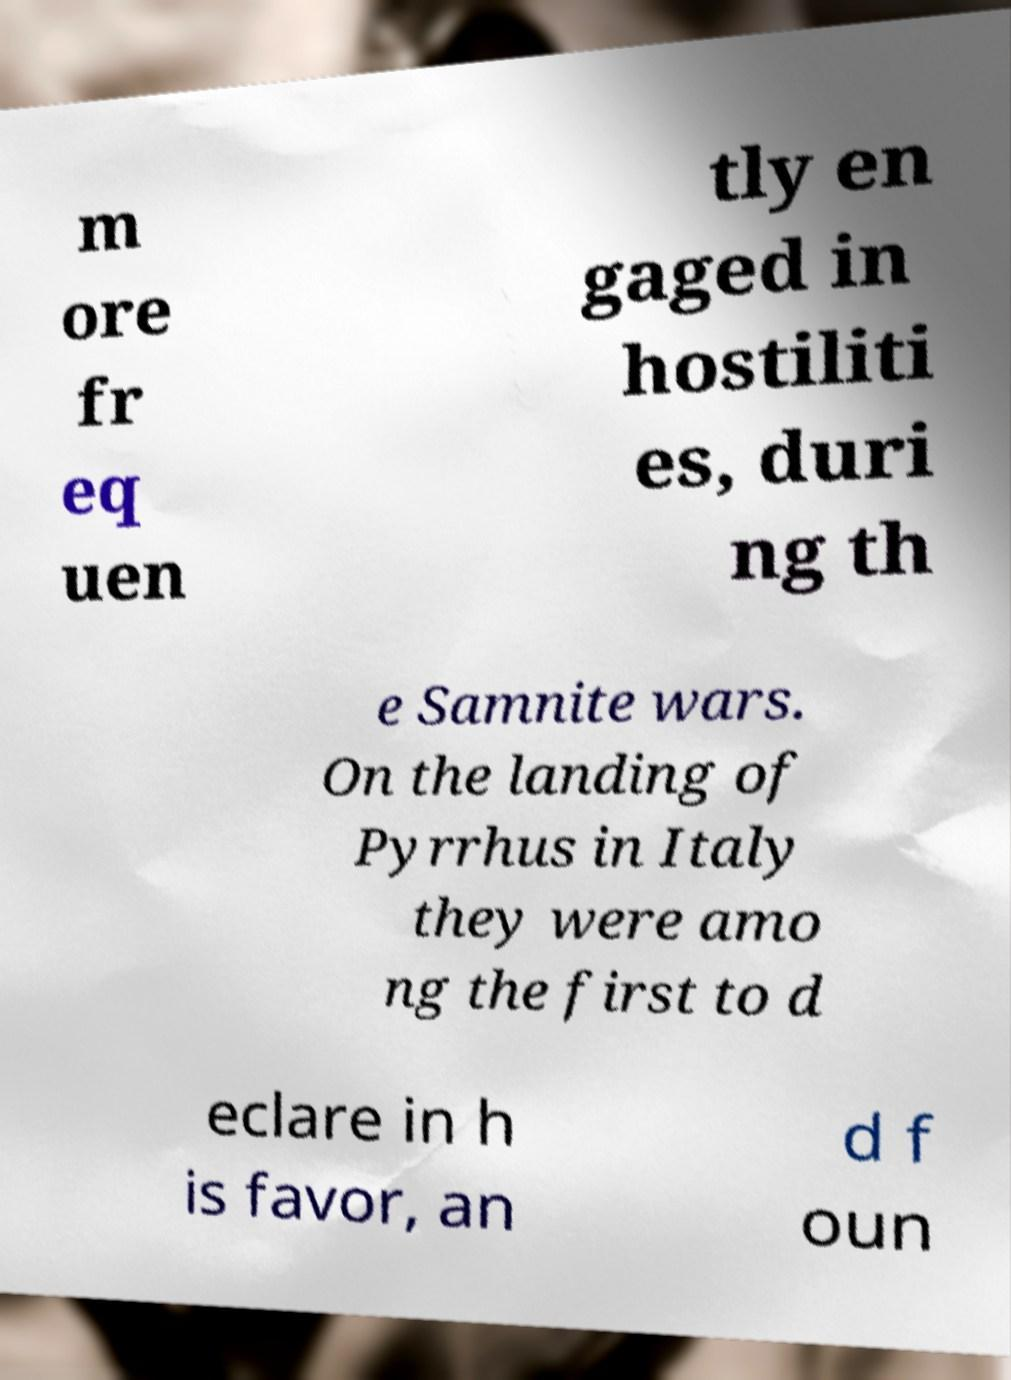What messages or text are displayed in this image? I need them in a readable, typed format. m ore fr eq uen tly en gaged in hostiliti es, duri ng th e Samnite wars. On the landing of Pyrrhus in Italy they were amo ng the first to d eclare in h is favor, an d f oun 